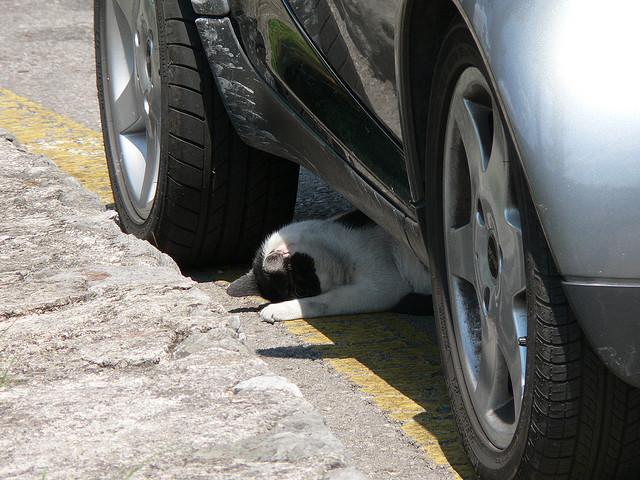Is the car parked in a driveway?
Short answer required. No. What is the cat using to hide its face?
Short answer required. Paw. Is the car parked illegally?
Concise answer only. Yes. 